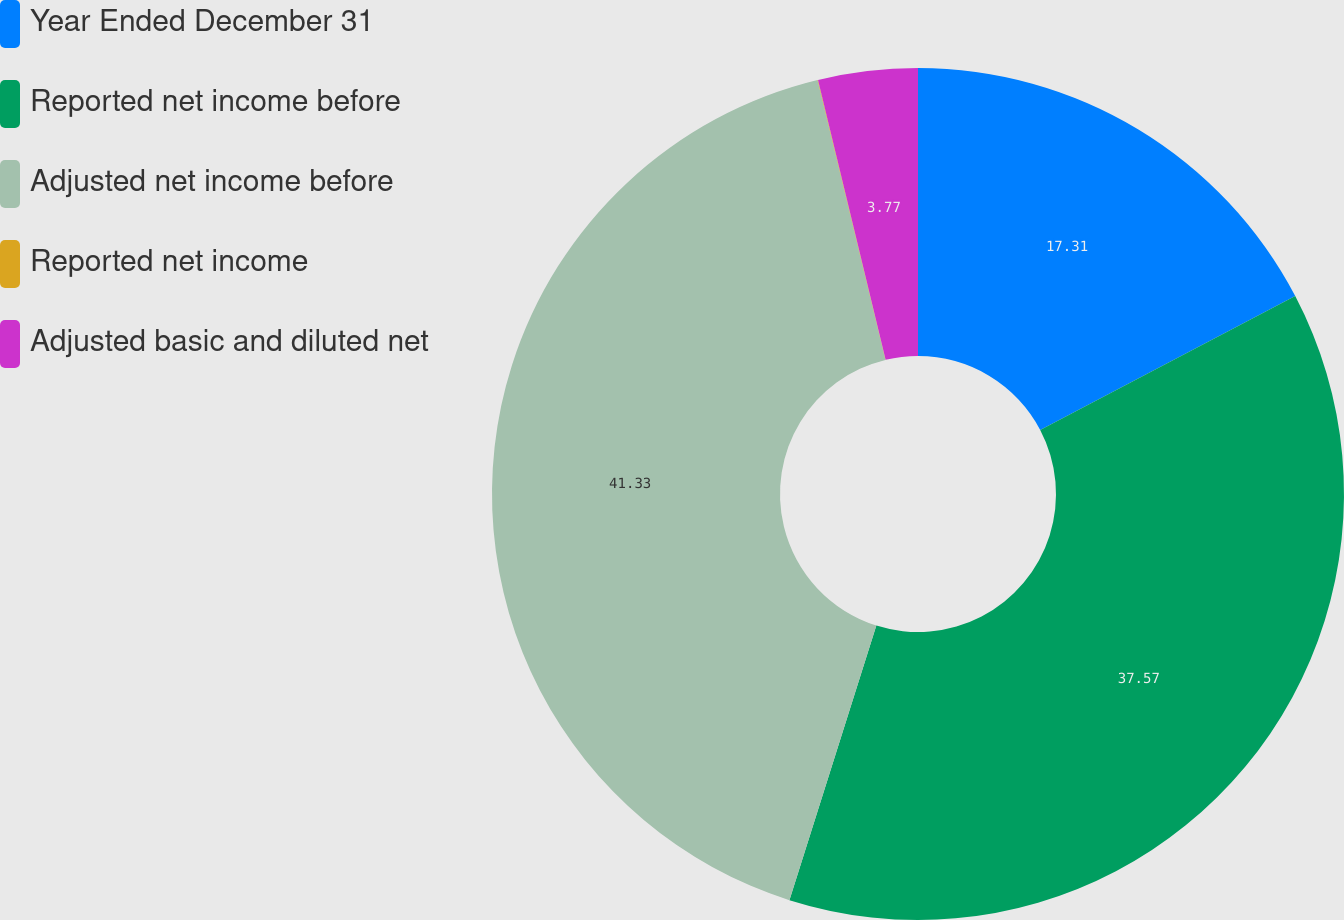Convert chart. <chart><loc_0><loc_0><loc_500><loc_500><pie_chart><fcel>Year Ended December 31<fcel>Reported net income before<fcel>Adjusted net income before<fcel>Reported net income<fcel>Adjusted basic and diluted net<nl><fcel>17.31%<fcel>37.57%<fcel>41.33%<fcel>0.02%<fcel>3.77%<nl></chart> 